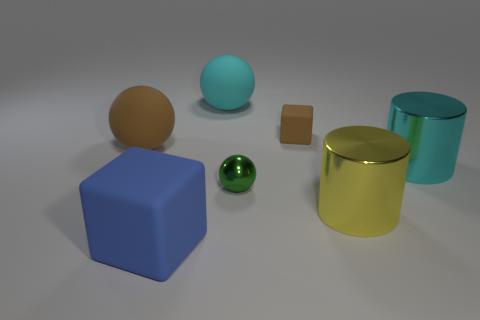Is there any other thing that has the same material as the big cyan ball?
Ensure brevity in your answer.  Yes. The brown object to the left of the big cyan matte object that is behind the big rubber block that is in front of the big cyan metal thing is made of what material?
Offer a very short reply. Rubber. The large thing that is both on the right side of the cyan ball and in front of the small green metal sphere is made of what material?
Your answer should be compact. Metal. How many other things have the same shape as the blue rubber object?
Your answer should be very brief. 1. What size is the cyan thing that is in front of the large cyan thing that is left of the small matte object?
Provide a succinct answer. Large. Does the rubber thing in front of the yellow metal cylinder have the same color as the big metallic object in front of the metallic ball?
Your response must be concise. No. There is a large rubber sphere to the left of the cube left of the tiny metallic thing; what number of spheres are in front of it?
Ensure brevity in your answer.  1. What number of matte things are both in front of the green object and right of the small green shiny thing?
Offer a terse response. 0. Is the number of things that are in front of the yellow metallic cylinder greater than the number of cylinders?
Ensure brevity in your answer.  No. What number of brown matte things are the same size as the cyan shiny thing?
Provide a short and direct response. 1. 